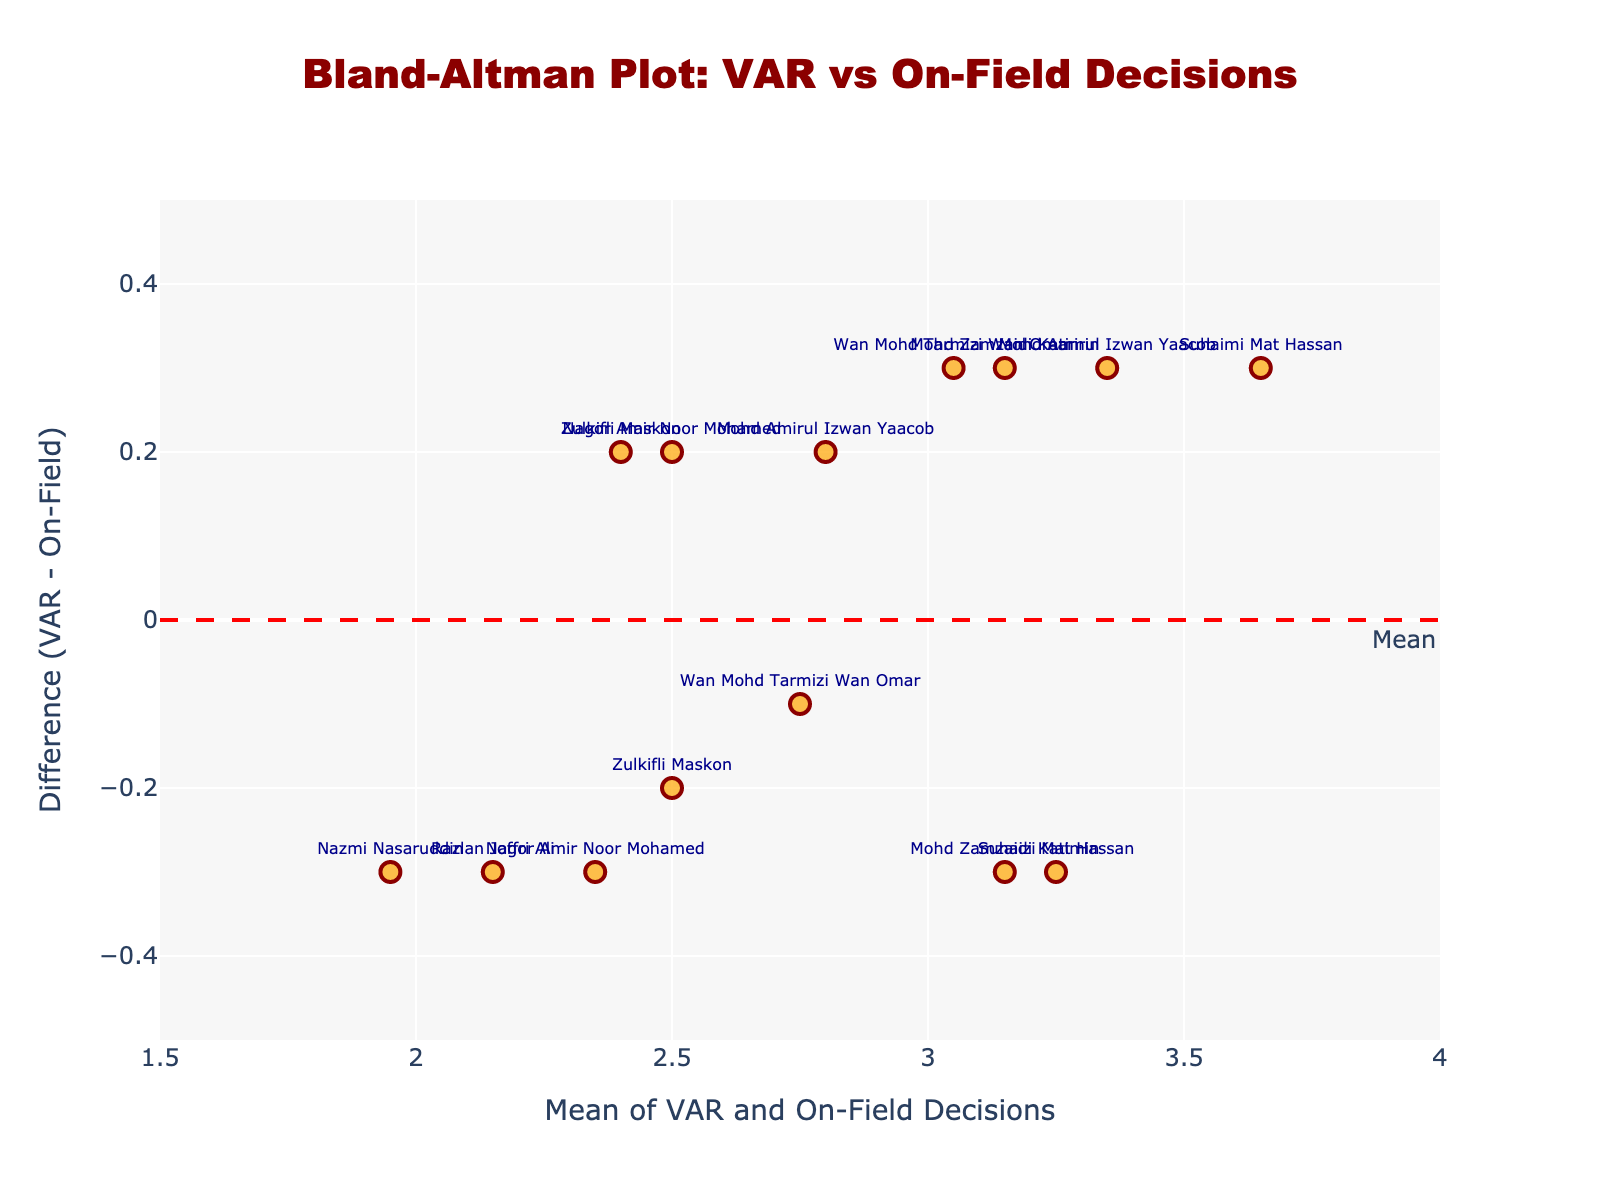What is the title of the plot? The title is always displayed at the top of the plot. According to the given code, the title should be "Bland-Altman Plot: VAR vs On-Field Decisions".
Answer: Bland-Altman Plot: VAR vs On-Field Decisions What are the x and y-axis titles? Referring to the plot layout in the code, the x-axis title is "Mean of VAR and On-Field Decisions", and the y-axis title is "Difference (VAR - On-Field)".
Answer: Mean of VAR and On-Field Decisions, Difference (VAR - On-Field) What color are the data points? By referring to the marker color settings in the code, the data points have an orange shade.
Answer: orange What is the mean difference (VAR - On-Field)? The mean difference is shown by the red dashed line annotated with "Mean".
Answer: approximately 0.0 How many data points fall outside the limits of agreement? To find this, count the number of points that are above the +1.96 SD line or below the -1.96 SD line. According to the plot, there are no points outside these limits.
Answer: 0 What is the difference for Suhaizi Mat Hassan? Locate Suhaizi Mat Hassan on the plot and read the corresponding y-value. Suhaizi Mat Hassan has two entries: +0.3 and -0.3.
Answer: +0.3, -0.3 Which referees have positive differences? Referees with data points above the mean line have positive differences. By inspecting the plot, the referees are Zulkifli Maskon, Mohd Amirul Izwan Yaacob, Mohd Zamzaidi Katimin, and Wan Mohd Tarmizi Wan Omar.
Answer: Zulkifli Maskon, Mohd Amirul Izwan Yaacob, Mohd Zamzaidi Katimin, Wan Mohd Tarmizi Wan Omar Which referee has the highest positive difference? Look for the highest data point above the mean line. Mohd Zamzaidi Katimin and Wan Mohd Tarmizi Wan Omar have the highest positive difference of +0.3.
Answer: Mohd Zamzaidi Katimin, Wan Mohd Tarmizi Wan Omar What range does the y-axis cover? Check the range settings for the y-axis in the plot code. The y-axis ranges from -0.5 to 0.5.
Answer: -0.5 to 0.5 Is there a trend in the differences related to the mean of VAR and On-Field Decisions? Examine whether the differences (y-axis) increase or decrease as the mean (x-axis) increases. The plot does not show a clear upward or downward trend.
Answer: No clear trend 